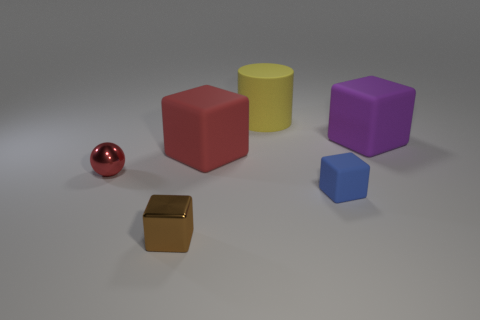Is the number of red things that are to the left of the cylinder greater than the number of gray shiny cylinders?
Your response must be concise. Yes. What number of other things are the same size as the blue matte cube?
Your answer should be very brief. 2. There is a tiny metal thing that is right of the red thing left of the shiny thing on the right side of the ball; what color is it?
Provide a short and direct response. Brown. There is a shiny object in front of the tiny object that is behind the small blue matte object; how many small brown objects are to the left of it?
Your answer should be very brief. 0. Are there any other things of the same color as the shiny block?
Make the answer very short. No. Is the size of the matte object on the left side of the yellow cylinder the same as the large yellow cylinder?
Keep it short and to the point. Yes. There is a red thing on the right side of the tiny red metal ball; what number of objects are to the left of it?
Provide a short and direct response. 2. There is a tiny metal thing that is in front of the metallic thing behind the brown cube; is there a red object left of it?
Give a very brief answer. Yes. There is another tiny object that is the same shape as the small blue object; what is it made of?
Provide a short and direct response. Metal. Do the big purple object and the large block that is on the left side of the purple matte block have the same material?
Provide a short and direct response. Yes. 